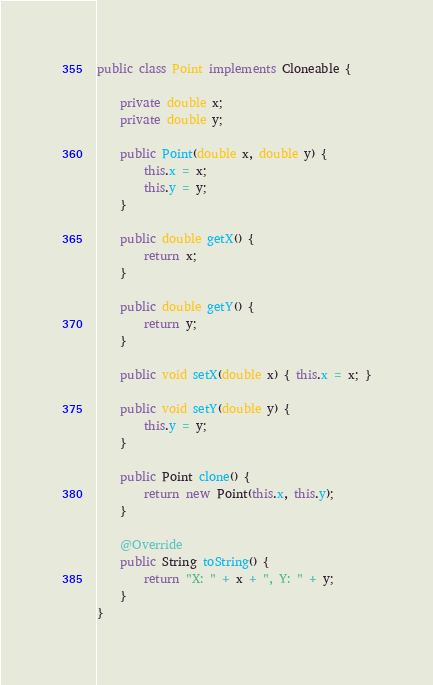Convert code to text. <code><loc_0><loc_0><loc_500><loc_500><_Java_>public class Point implements Cloneable {

    private double x;
    private double y;

    public Point(double x, double y) {
        this.x = x;
        this.y = y;
    }

    public double getX() {
        return x;
    }

    public double getY() {
        return y;
    }

    public void setX(double x) { this.x = x; }

    public void setY(double y) {
        this.y = y;
    }

    public Point clone() {
        return new Point(this.x, this.y);
    }

    @Override
    public String toString() {
        return "X: " + x + ", Y: " + y;
    }
}
</code> 